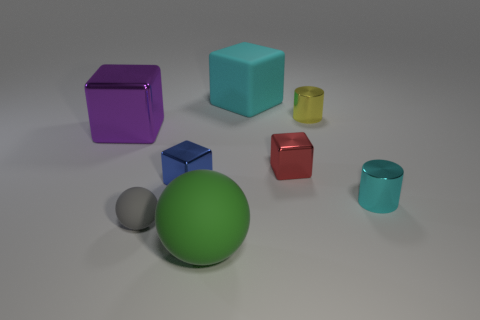Subtract all cyan blocks. How many blocks are left? 3 Subtract all purple cubes. How many cubes are left? 3 Add 2 big brown metallic cylinders. How many objects exist? 10 Subtract all red cubes. Subtract all green balls. How many cubes are left? 3 Subtract all cylinders. How many objects are left? 6 Subtract all small metal things. Subtract all small blue metallic blocks. How many objects are left? 3 Add 6 small yellow metal things. How many small yellow metal things are left? 7 Add 7 yellow shiny things. How many yellow shiny things exist? 8 Subtract 0 purple cylinders. How many objects are left? 8 